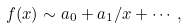Convert formula to latex. <formula><loc_0><loc_0><loc_500><loc_500>f ( x ) \sim a _ { 0 } + a _ { 1 } / x + \cdots ,</formula> 